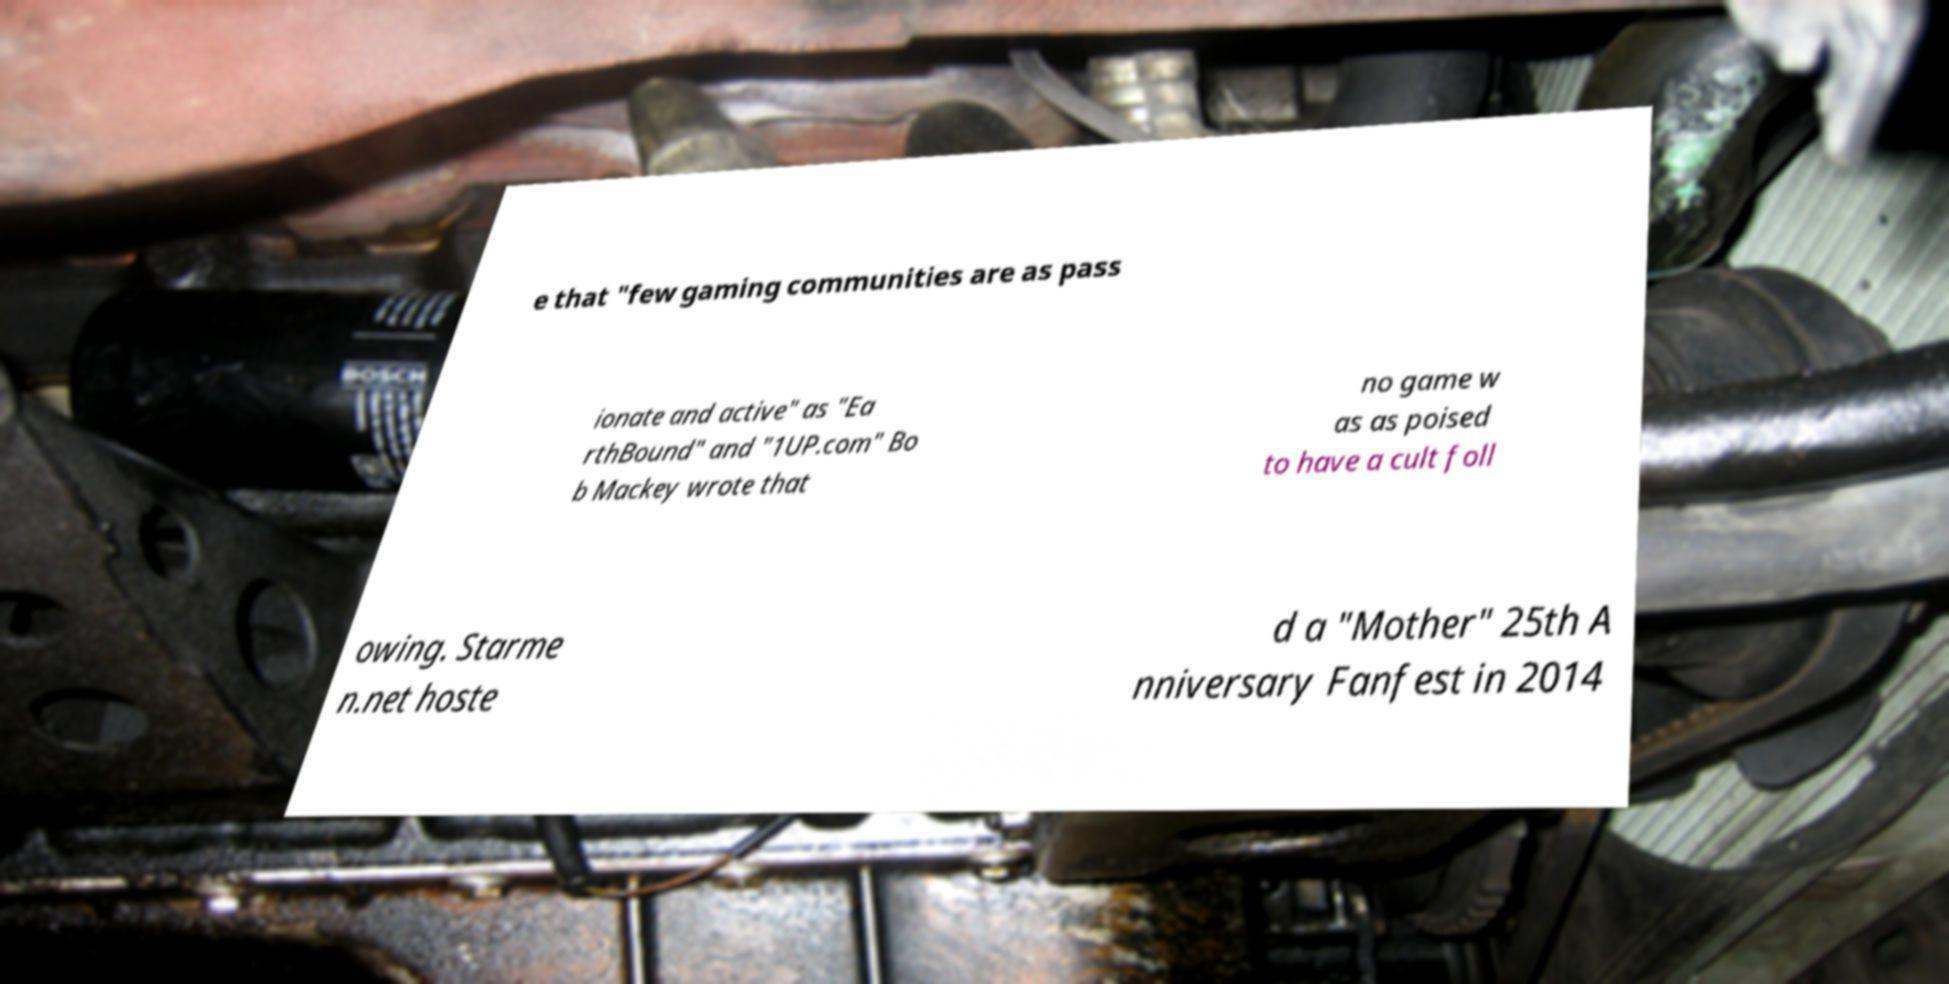What messages or text are displayed in this image? I need them in a readable, typed format. e that "few gaming communities are as pass ionate and active" as "Ea rthBound" and "1UP.com" Bo b Mackey wrote that no game w as as poised to have a cult foll owing. Starme n.net hoste d a "Mother" 25th A nniversary Fanfest in 2014 